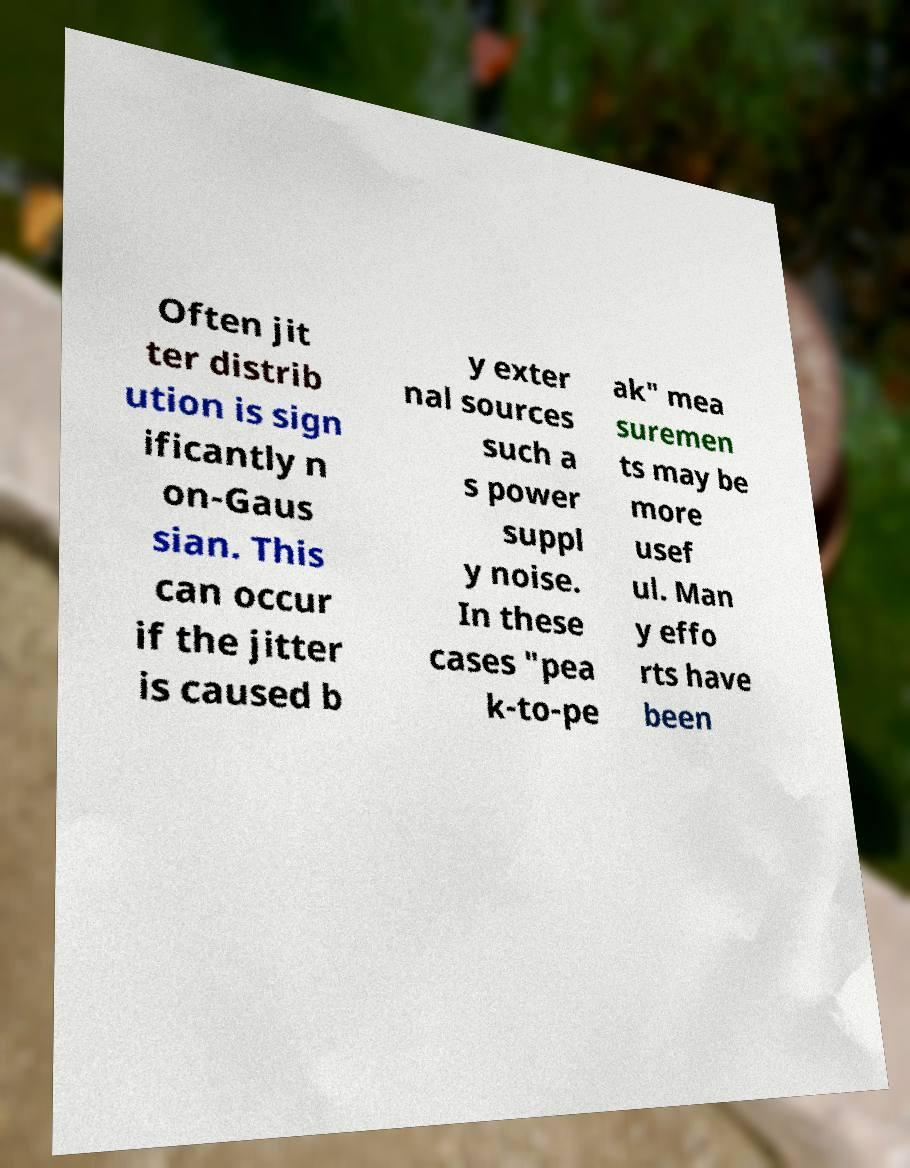Could you assist in decoding the text presented in this image and type it out clearly? Often jit ter distrib ution is sign ificantly n on-Gaus sian. This can occur if the jitter is caused b y exter nal sources such a s power suppl y noise. In these cases "pea k-to-pe ak" mea suremen ts may be more usef ul. Man y effo rts have been 